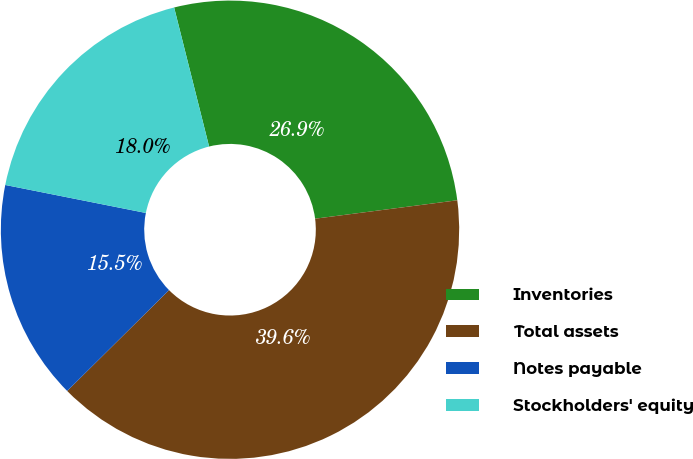Convert chart to OTSL. <chart><loc_0><loc_0><loc_500><loc_500><pie_chart><fcel>Inventories<fcel>Total assets<fcel>Notes payable<fcel>Stockholders' equity<nl><fcel>26.87%<fcel>39.63%<fcel>15.55%<fcel>17.95%<nl></chart> 